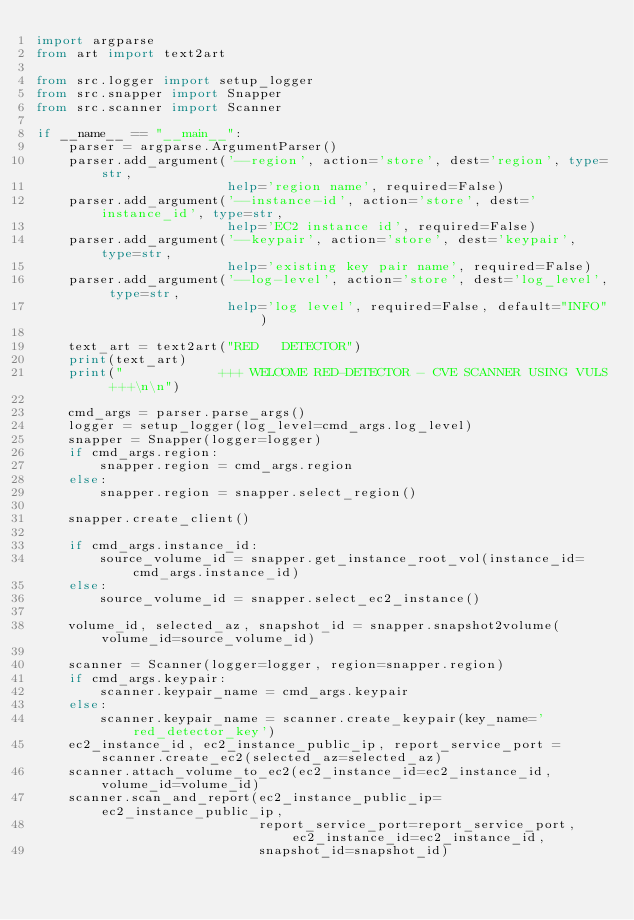Convert code to text. <code><loc_0><loc_0><loc_500><loc_500><_Python_>import argparse
from art import text2art

from src.logger import setup_logger
from src.snapper import Snapper
from src.scanner import Scanner

if __name__ == "__main__":
    parser = argparse.ArgumentParser()
    parser.add_argument('--region', action='store', dest='region', type=str,
                        help='region name', required=False)
    parser.add_argument('--instance-id', action='store', dest='instance_id', type=str,
                        help='EC2 instance id', required=False)
    parser.add_argument('--keypair', action='store', dest='keypair', type=str,
                        help='existing key pair name', required=False)
    parser.add_argument('--log-level', action='store', dest='log_level', type=str,
                        help='log level', required=False, default="INFO")

    text_art = text2art("RED   DETECTOR")
    print(text_art)
    print("            +++ WELCOME RED-DETECTOR - CVE SCANNER USING VULS +++\n\n")

    cmd_args = parser.parse_args()
    logger = setup_logger(log_level=cmd_args.log_level)
    snapper = Snapper(logger=logger)
    if cmd_args.region:
        snapper.region = cmd_args.region
    else:
        snapper.region = snapper.select_region()

    snapper.create_client()

    if cmd_args.instance_id:
        source_volume_id = snapper.get_instance_root_vol(instance_id=cmd_args.instance_id)
    else:
        source_volume_id = snapper.select_ec2_instance()

    volume_id, selected_az, snapshot_id = snapper.snapshot2volume(volume_id=source_volume_id)

    scanner = Scanner(logger=logger, region=snapper.region)
    if cmd_args.keypair:
        scanner.keypair_name = cmd_args.keypair
    else:
        scanner.keypair_name = scanner.create_keypair(key_name='red_detector_key')
    ec2_instance_id, ec2_instance_public_ip, report_service_port = scanner.create_ec2(selected_az=selected_az)
    scanner.attach_volume_to_ec2(ec2_instance_id=ec2_instance_id, volume_id=volume_id)
    scanner.scan_and_report(ec2_instance_public_ip=ec2_instance_public_ip,
                            report_service_port=report_service_port, ec2_instance_id=ec2_instance_id,
                            snapshot_id=snapshot_id)
</code> 